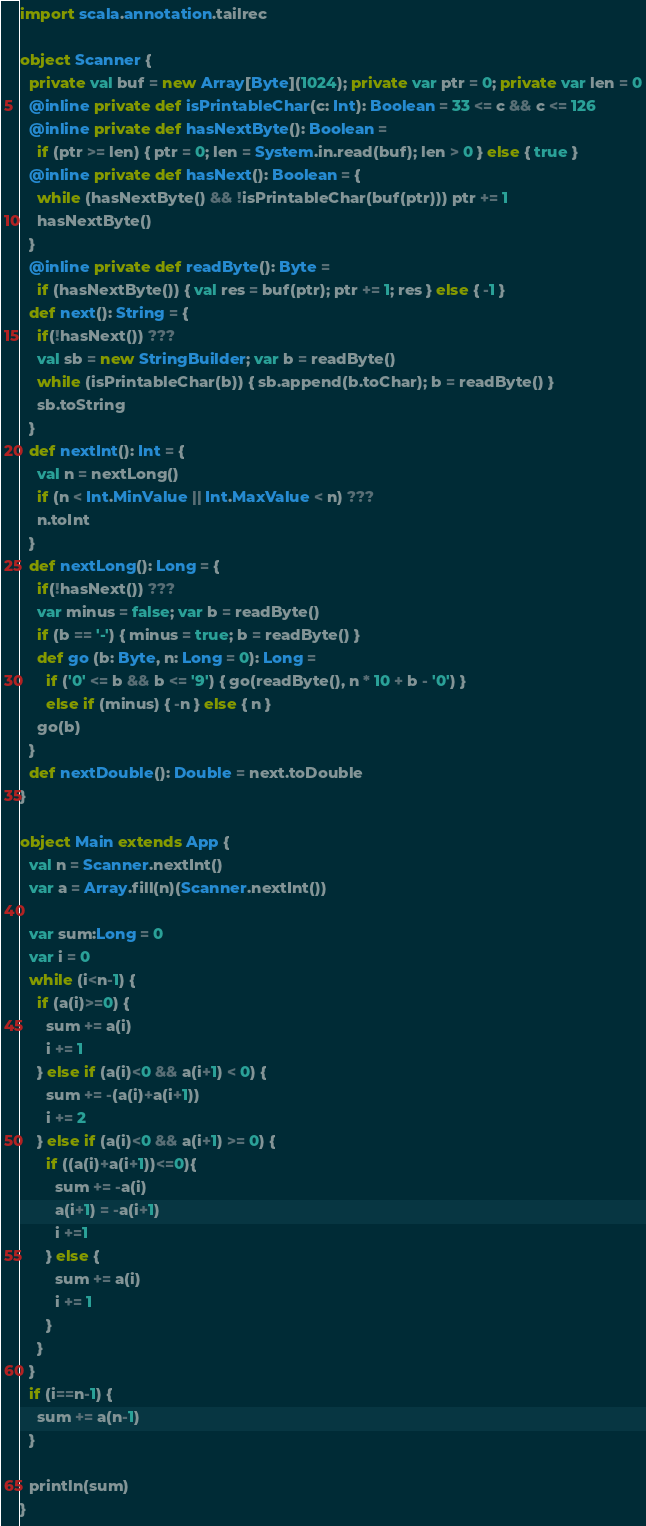Convert code to text. <code><loc_0><loc_0><loc_500><loc_500><_Scala_>import scala.annotation.tailrec

object Scanner {
  private val buf = new Array[Byte](1024); private var ptr = 0; private var len = 0
  @inline private def isPrintableChar(c: Int): Boolean = 33 <= c && c <= 126
  @inline private def hasNextByte(): Boolean =
    if (ptr >= len) { ptr = 0; len = System.in.read(buf); len > 0 } else { true }
  @inline private def hasNext(): Boolean = {
    while (hasNextByte() && !isPrintableChar(buf(ptr))) ptr += 1
    hasNextByte()
  }
  @inline private def readByte(): Byte =
    if (hasNextByte()) { val res = buf(ptr); ptr += 1; res } else { -1 }
  def next(): String = {
    if(!hasNext()) ???
    val sb = new StringBuilder; var b = readByte()
    while (isPrintableChar(b)) { sb.append(b.toChar); b = readByte() }
    sb.toString
  }
  def nextInt(): Int = {
    val n = nextLong()
    if (n < Int.MinValue || Int.MaxValue < n) ???
    n.toInt
  }
  def nextLong(): Long = {
    if(!hasNext()) ???
    var minus = false; var b = readByte()
    if (b == '-') { minus = true; b = readByte() }
    def go (b: Byte, n: Long = 0): Long =
      if ('0' <= b && b <= '9') { go(readByte(), n * 10 + b - '0') }
      else if (minus) { -n } else { n }
    go(b)
  }
  def nextDouble(): Double = next.toDouble
}

object Main extends App {
  val n = Scanner.nextInt()
  var a = Array.fill(n)(Scanner.nextInt())

  var sum:Long = 0
  var i = 0
  while (i<n-1) {
    if (a(i)>=0) {
      sum += a(i)
      i += 1
    } else if (a(i)<0 && a(i+1) < 0) {
      sum += -(a(i)+a(i+1))
      i += 2
    } else if (a(i)<0 && a(i+1) >= 0) {
      if ((a(i)+a(i+1))<=0){
        sum += -a(i)
        a(i+1) = -a(i+1)
        i +=1
      } else {
        sum += a(i)
        i += 1
      }
    }
  }
  if (i==n-1) {
    sum += a(n-1)
  }

  println(sum)
}</code> 